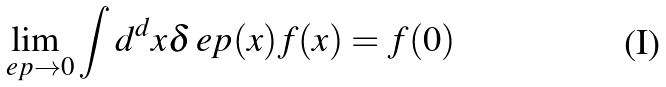<formula> <loc_0><loc_0><loc_500><loc_500>\lim _ { \ e p \to 0 } \int d ^ { d } x \delta _ { \ } e p ( x ) f ( x ) = f ( 0 )</formula> 